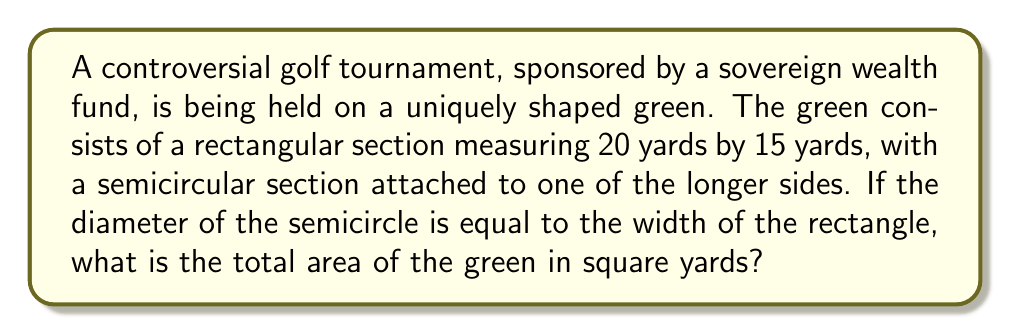Solve this math problem. Let's approach this step-by-step:

1) First, we need to calculate the area of the rectangular section:
   $$A_{rectangle} = length \times width$$
   $$A_{rectangle} = 20 \times 15 = 300 \text{ sq yards}$$

2) Now, for the semicircular section:
   The diameter of the semicircle is equal to the width of the rectangle, which is 15 yards.
   So, the radius of the semicircle is half of this: $r = 15/2 = 7.5 \text{ yards}$

3) The area of a full circle is given by $\pi r^2$, so the area of a semicircle is half of this:
   $$A_{semicircle} = \frac{1}{2} \pi r^2$$
   $$A_{semicircle} = \frac{1}{2} \times \pi \times (7.5)^2$$
   $$A_{semicircle} = \frac{1}{2} \times \pi \times 56.25$$
   $$A_{semicircle} \approx 88.36 \text{ sq yards}$$

4) The total area of the green is the sum of these two areas:
   $$A_{total} = A_{rectangle} + A_{semicircle}$$
   $$A_{total} = 300 + 88.36 = 388.36 \text{ sq yards}$$

5) Rounding to the nearest square yard:
   $$A_{total} \approx 388 \text{ sq yards}$$
Answer: 388 sq yards 